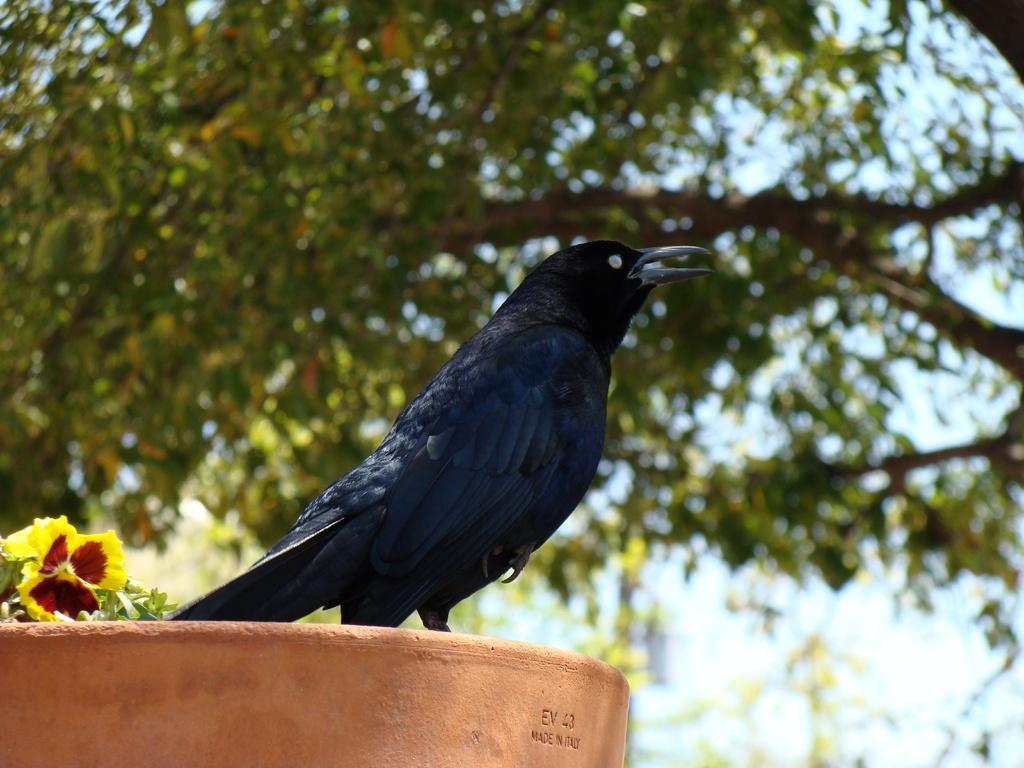Can you describe this image briefly? This image consists of a crow. On the left, there is a flower. In the background, there are trees. At the bottom, it looks like a wall. 